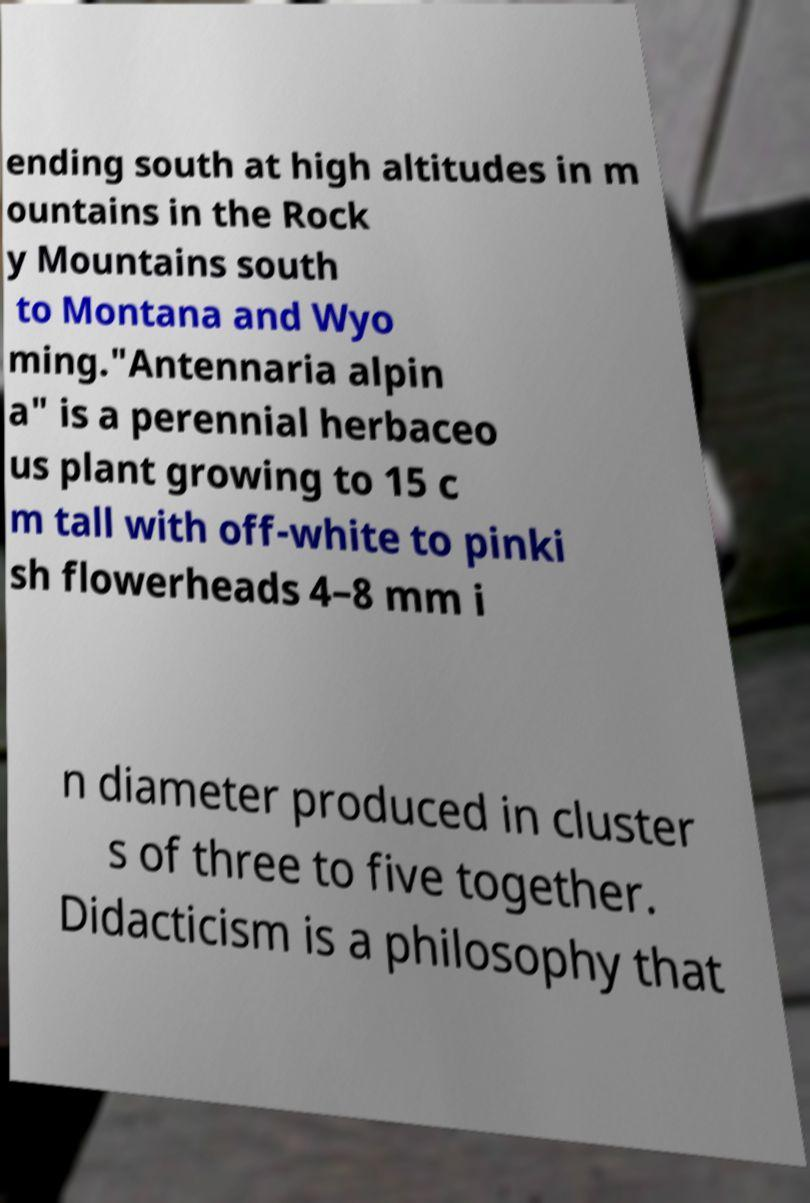Can you accurately transcribe the text from the provided image for me? ending south at high altitudes in m ountains in the Rock y Mountains south to Montana and Wyo ming."Antennaria alpin a" is a perennial herbaceo us plant growing to 15 c m tall with off-white to pinki sh flowerheads 4–8 mm i n diameter produced in cluster s of three to five together. Didacticism is a philosophy that 